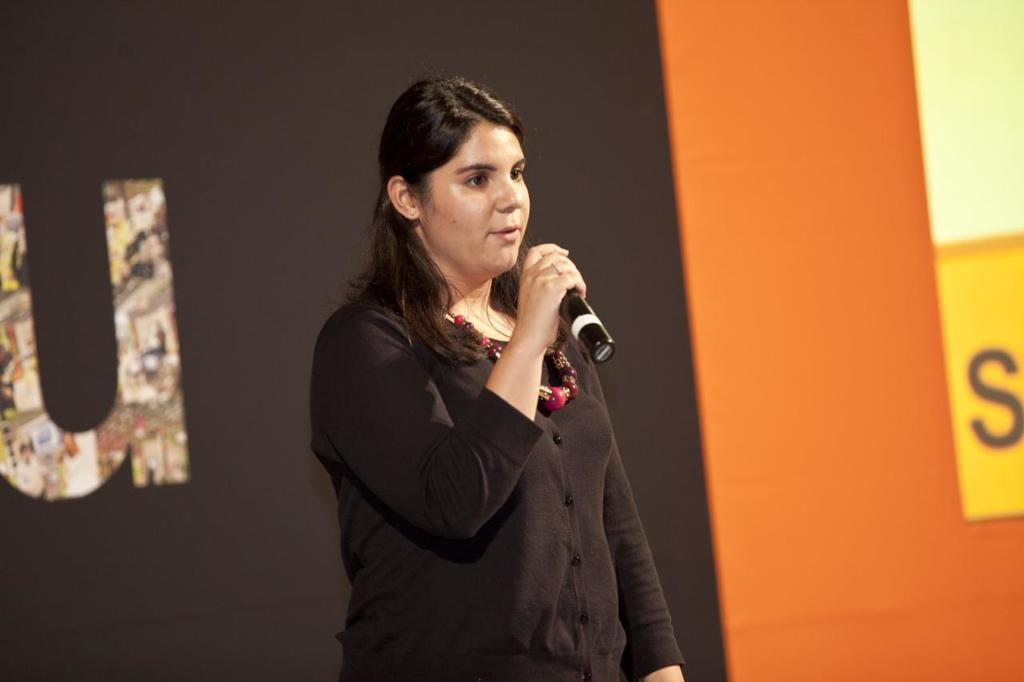Who is the main subject in the image? There is a woman in the image. What is the woman wearing? The woman is wearing a black dress and an ornament. What is the woman holding in the image? The woman is holding a microphone. What is the woman doing in the image? The woman is talking. What can be seen in the background of the image? There is a board in the background of the image with text printed on it. What type of bean is the woman holding in the image? There is no bean present in the image; the woman is holding a microphone. What does the woman need to do in order to reach an agreement in the image? There is no indication of an agreement or negotiation in the image; the woman is simply talking while holding a microphone. 